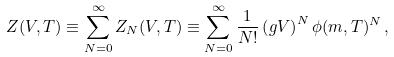<formula> <loc_0><loc_0><loc_500><loc_500>Z ( V , T ) \equiv \sum _ { N = 0 } ^ { \infty } Z _ { N } ( V , T ) \equiv \sum _ { N = 0 } ^ { \infty } \frac { 1 } { N ! } \left ( g V \right ) ^ { N } \phi ( m , T ) ^ { N } \, ,</formula> 